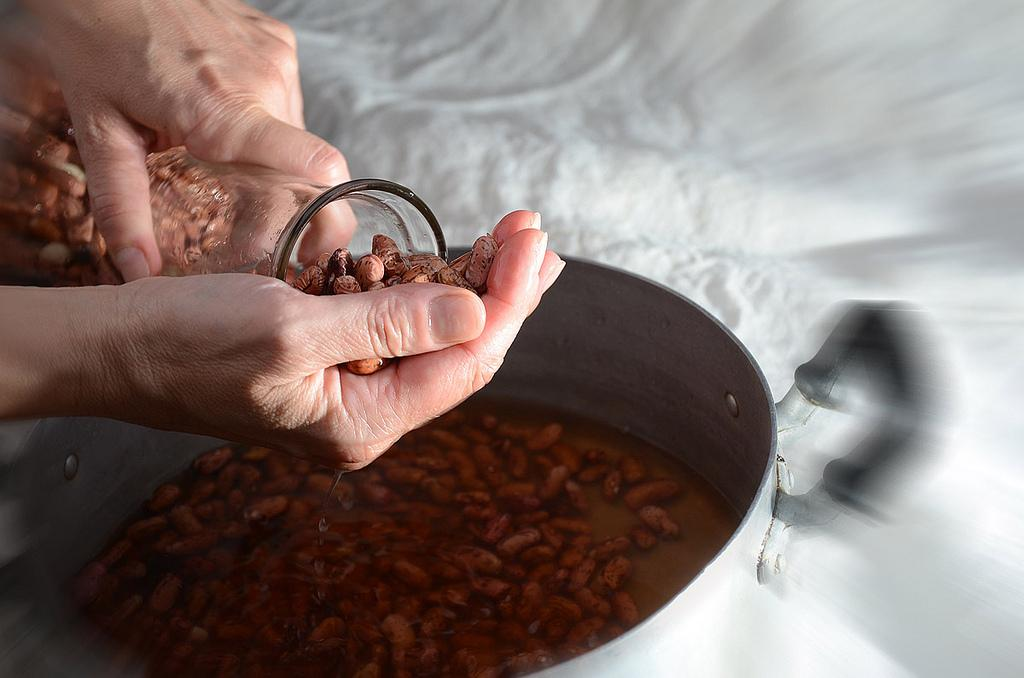How many hands are visible in the image? There are two hands in the image. What object can be seen alongside the hands? There is a bottle in the image. What else is present in the image besides the hands and the bottle? There is a vessel in the image. Can you describe the contents of the vessel? There is something inside the vessel. What is the weight of the dirt visible in the image? There is no dirt present in the image, so it is not possible to determine its weight. 